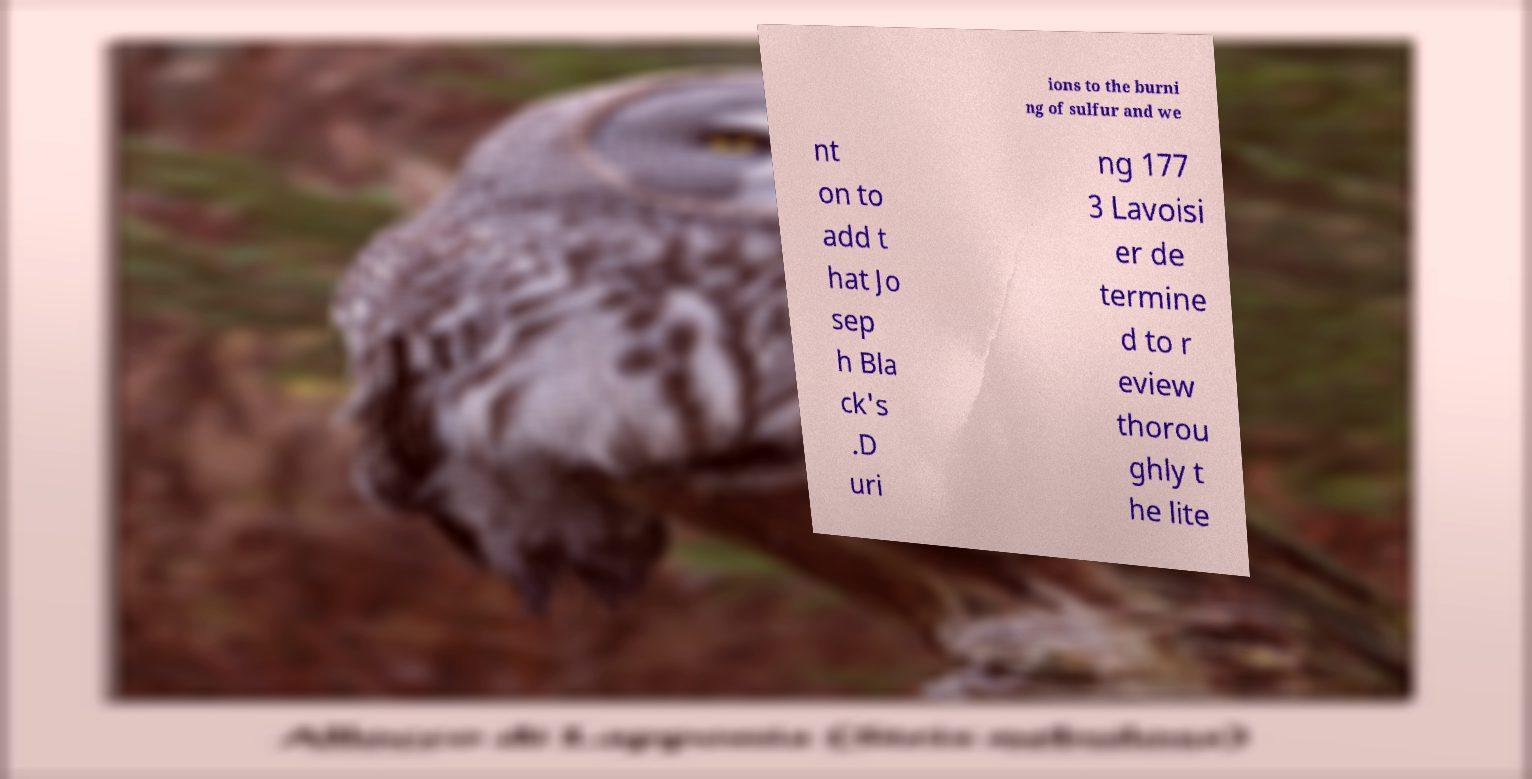Could you extract and type out the text from this image? ions to the burni ng of sulfur and we nt on to add t hat Jo sep h Bla ck's .D uri ng 177 3 Lavoisi er de termine d to r eview thorou ghly t he lite 